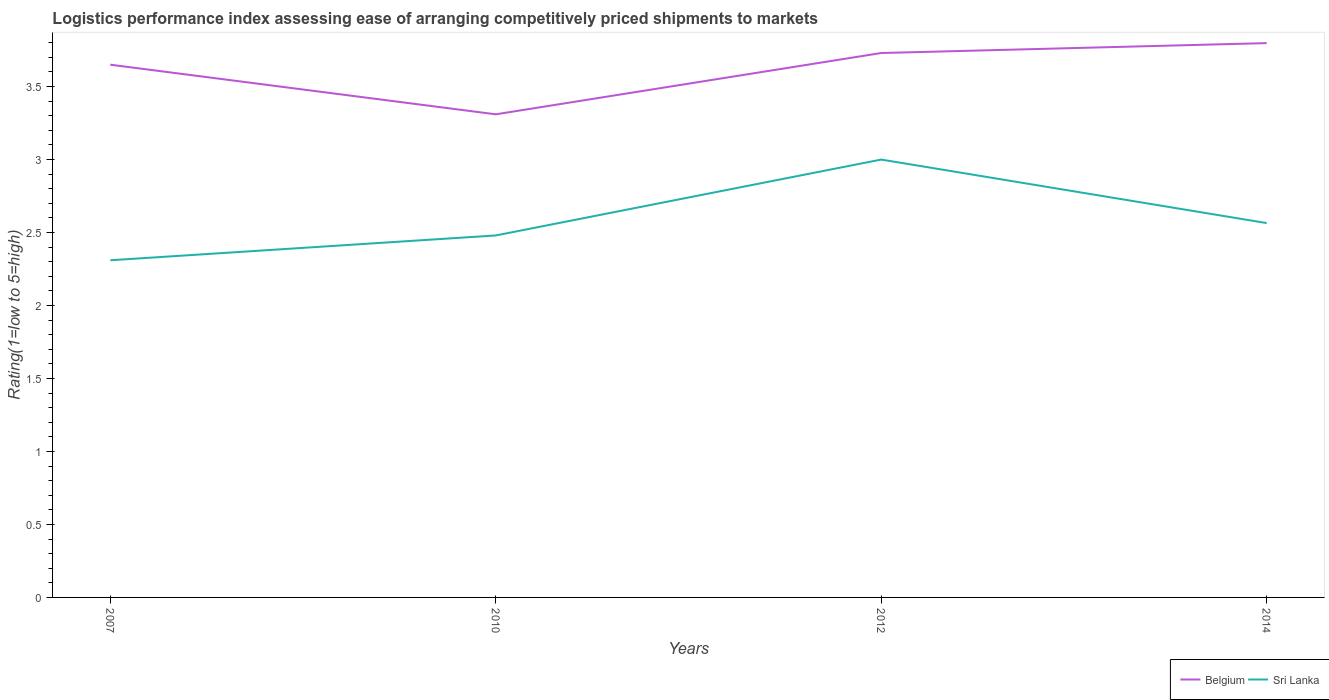Does the line corresponding to Belgium intersect with the line corresponding to Sri Lanka?
Make the answer very short. No. Across all years, what is the maximum Logistic performance index in Sri Lanka?
Your answer should be very brief. 2.31. What is the total Logistic performance index in Sri Lanka in the graph?
Offer a terse response. -0.25. What is the difference between the highest and the second highest Logistic performance index in Sri Lanka?
Ensure brevity in your answer.  0.69. How many years are there in the graph?
Your answer should be very brief. 4. Are the values on the major ticks of Y-axis written in scientific E-notation?
Provide a succinct answer. No. Does the graph contain any zero values?
Ensure brevity in your answer.  No. Does the graph contain grids?
Offer a very short reply. No. How are the legend labels stacked?
Keep it short and to the point. Horizontal. What is the title of the graph?
Ensure brevity in your answer.  Logistics performance index assessing ease of arranging competitively priced shipments to markets. What is the label or title of the Y-axis?
Your response must be concise. Rating(1=low to 5=high). What is the Rating(1=low to 5=high) of Belgium in 2007?
Keep it short and to the point. 3.65. What is the Rating(1=low to 5=high) of Sri Lanka in 2007?
Keep it short and to the point. 2.31. What is the Rating(1=low to 5=high) in Belgium in 2010?
Make the answer very short. 3.31. What is the Rating(1=low to 5=high) in Sri Lanka in 2010?
Ensure brevity in your answer.  2.48. What is the Rating(1=low to 5=high) in Belgium in 2012?
Give a very brief answer. 3.73. What is the Rating(1=low to 5=high) of Belgium in 2014?
Your answer should be compact. 3.8. What is the Rating(1=low to 5=high) in Sri Lanka in 2014?
Provide a succinct answer. 2.56. Across all years, what is the maximum Rating(1=low to 5=high) in Belgium?
Ensure brevity in your answer.  3.8. Across all years, what is the maximum Rating(1=low to 5=high) in Sri Lanka?
Your answer should be very brief. 3. Across all years, what is the minimum Rating(1=low to 5=high) in Belgium?
Your answer should be very brief. 3.31. Across all years, what is the minimum Rating(1=low to 5=high) in Sri Lanka?
Ensure brevity in your answer.  2.31. What is the total Rating(1=low to 5=high) of Belgium in the graph?
Your answer should be compact. 14.49. What is the total Rating(1=low to 5=high) in Sri Lanka in the graph?
Your answer should be compact. 10.35. What is the difference between the Rating(1=low to 5=high) in Belgium in 2007 and that in 2010?
Ensure brevity in your answer.  0.34. What is the difference between the Rating(1=low to 5=high) in Sri Lanka in 2007 and that in 2010?
Provide a short and direct response. -0.17. What is the difference between the Rating(1=low to 5=high) in Belgium in 2007 and that in 2012?
Provide a succinct answer. -0.08. What is the difference between the Rating(1=low to 5=high) of Sri Lanka in 2007 and that in 2012?
Your response must be concise. -0.69. What is the difference between the Rating(1=low to 5=high) of Belgium in 2007 and that in 2014?
Your response must be concise. -0.15. What is the difference between the Rating(1=low to 5=high) in Sri Lanka in 2007 and that in 2014?
Ensure brevity in your answer.  -0.25. What is the difference between the Rating(1=low to 5=high) in Belgium in 2010 and that in 2012?
Keep it short and to the point. -0.42. What is the difference between the Rating(1=low to 5=high) of Sri Lanka in 2010 and that in 2012?
Give a very brief answer. -0.52. What is the difference between the Rating(1=low to 5=high) of Belgium in 2010 and that in 2014?
Your answer should be compact. -0.49. What is the difference between the Rating(1=low to 5=high) of Sri Lanka in 2010 and that in 2014?
Your answer should be compact. -0.08. What is the difference between the Rating(1=low to 5=high) of Belgium in 2012 and that in 2014?
Give a very brief answer. -0.07. What is the difference between the Rating(1=low to 5=high) in Sri Lanka in 2012 and that in 2014?
Offer a terse response. 0.44. What is the difference between the Rating(1=low to 5=high) of Belgium in 2007 and the Rating(1=low to 5=high) of Sri Lanka in 2010?
Offer a terse response. 1.17. What is the difference between the Rating(1=low to 5=high) of Belgium in 2007 and the Rating(1=low to 5=high) of Sri Lanka in 2012?
Make the answer very short. 0.65. What is the difference between the Rating(1=low to 5=high) in Belgium in 2007 and the Rating(1=low to 5=high) in Sri Lanka in 2014?
Your answer should be compact. 1.09. What is the difference between the Rating(1=low to 5=high) in Belgium in 2010 and the Rating(1=low to 5=high) in Sri Lanka in 2012?
Provide a succinct answer. 0.31. What is the difference between the Rating(1=low to 5=high) of Belgium in 2010 and the Rating(1=low to 5=high) of Sri Lanka in 2014?
Your response must be concise. 0.75. What is the difference between the Rating(1=low to 5=high) of Belgium in 2012 and the Rating(1=low to 5=high) of Sri Lanka in 2014?
Offer a very short reply. 1.17. What is the average Rating(1=low to 5=high) in Belgium per year?
Offer a very short reply. 3.62. What is the average Rating(1=low to 5=high) of Sri Lanka per year?
Your answer should be compact. 2.59. In the year 2007, what is the difference between the Rating(1=low to 5=high) in Belgium and Rating(1=low to 5=high) in Sri Lanka?
Ensure brevity in your answer.  1.34. In the year 2010, what is the difference between the Rating(1=low to 5=high) in Belgium and Rating(1=low to 5=high) in Sri Lanka?
Ensure brevity in your answer.  0.83. In the year 2012, what is the difference between the Rating(1=low to 5=high) in Belgium and Rating(1=low to 5=high) in Sri Lanka?
Provide a succinct answer. 0.73. In the year 2014, what is the difference between the Rating(1=low to 5=high) of Belgium and Rating(1=low to 5=high) of Sri Lanka?
Your response must be concise. 1.23. What is the ratio of the Rating(1=low to 5=high) of Belgium in 2007 to that in 2010?
Offer a terse response. 1.1. What is the ratio of the Rating(1=low to 5=high) of Sri Lanka in 2007 to that in 2010?
Provide a succinct answer. 0.93. What is the ratio of the Rating(1=low to 5=high) of Belgium in 2007 to that in 2012?
Provide a short and direct response. 0.98. What is the ratio of the Rating(1=low to 5=high) in Sri Lanka in 2007 to that in 2012?
Offer a very short reply. 0.77. What is the ratio of the Rating(1=low to 5=high) of Belgium in 2007 to that in 2014?
Make the answer very short. 0.96. What is the ratio of the Rating(1=low to 5=high) in Sri Lanka in 2007 to that in 2014?
Provide a succinct answer. 0.9. What is the ratio of the Rating(1=low to 5=high) of Belgium in 2010 to that in 2012?
Provide a succinct answer. 0.89. What is the ratio of the Rating(1=low to 5=high) of Sri Lanka in 2010 to that in 2012?
Make the answer very short. 0.83. What is the ratio of the Rating(1=low to 5=high) of Belgium in 2010 to that in 2014?
Offer a very short reply. 0.87. What is the ratio of the Rating(1=low to 5=high) of Sri Lanka in 2010 to that in 2014?
Your answer should be very brief. 0.97. What is the ratio of the Rating(1=low to 5=high) in Belgium in 2012 to that in 2014?
Offer a terse response. 0.98. What is the ratio of the Rating(1=low to 5=high) in Sri Lanka in 2012 to that in 2014?
Your response must be concise. 1.17. What is the difference between the highest and the second highest Rating(1=low to 5=high) of Belgium?
Offer a very short reply. 0.07. What is the difference between the highest and the second highest Rating(1=low to 5=high) of Sri Lanka?
Ensure brevity in your answer.  0.44. What is the difference between the highest and the lowest Rating(1=low to 5=high) in Belgium?
Keep it short and to the point. 0.49. What is the difference between the highest and the lowest Rating(1=low to 5=high) in Sri Lanka?
Keep it short and to the point. 0.69. 